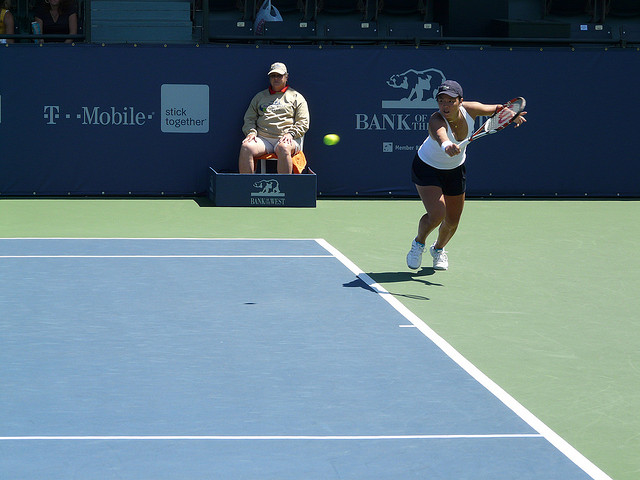Identify the text contained in this image. stick together -Mobile- TH OF BANK -T- 